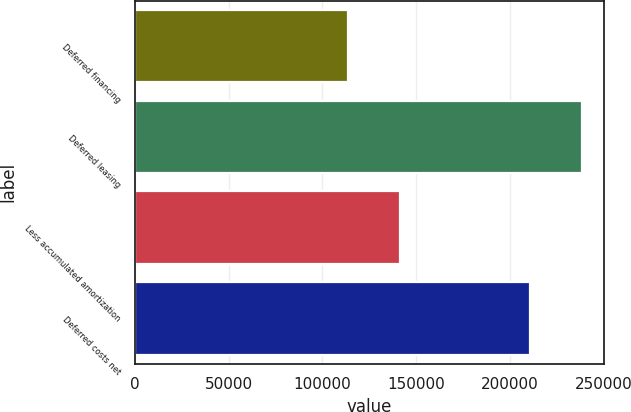<chart> <loc_0><loc_0><loc_500><loc_500><bar_chart><fcel>Deferred financing<fcel>Deferred leasing<fcel>Less accumulated amortization<fcel>Deferred costs net<nl><fcel>113620<fcel>238394<fcel>141228<fcel>210786<nl></chart> 